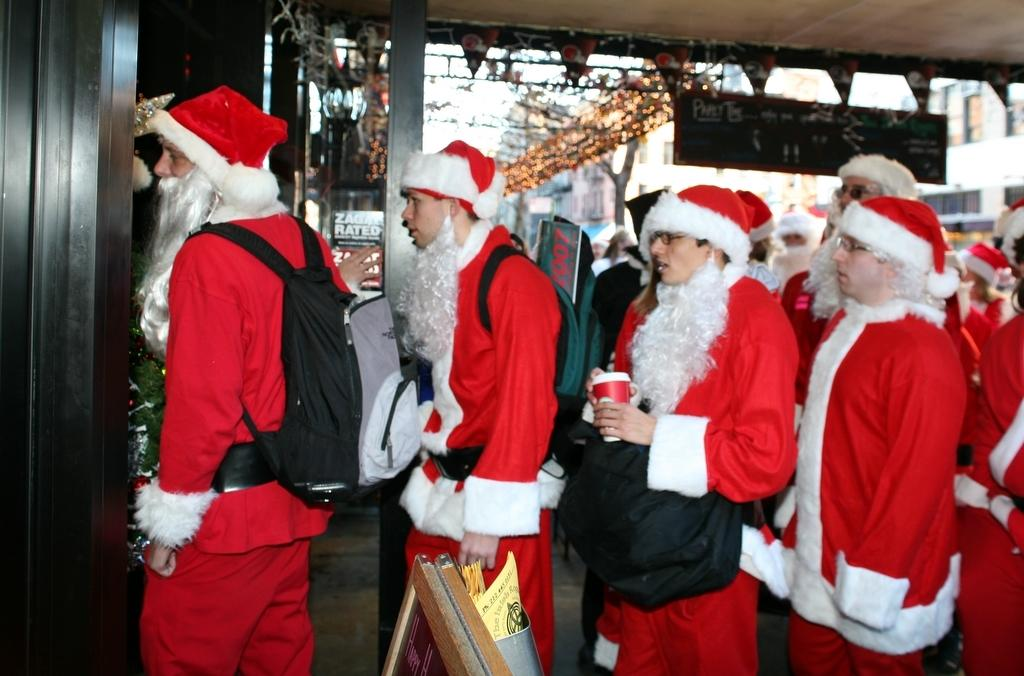How many people are in the image? There is a group of people in the image. What are the people wearing in the image? The people are wearing Santa Claus costumes. What can be seen in the image besides the people? There are boards, a tree decorated with balls, a light, and buildings in the image. How many brothers are present in the image? There is no information about brothers in the image; it only mentions a group of people wearing Santa Claus costumes. How many cats can be seen interacting with the with the people in the image? There are no cats present in the image. 